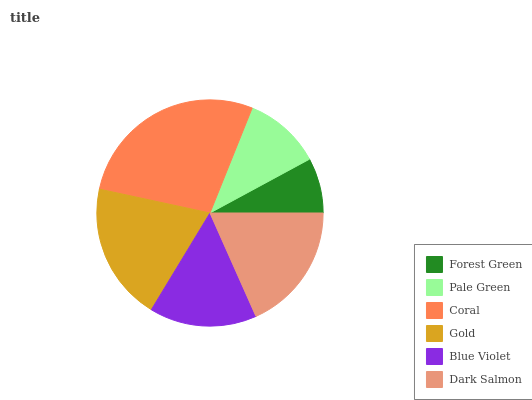Is Forest Green the minimum?
Answer yes or no. Yes. Is Coral the maximum?
Answer yes or no. Yes. Is Pale Green the minimum?
Answer yes or no. No. Is Pale Green the maximum?
Answer yes or no. No. Is Pale Green greater than Forest Green?
Answer yes or no. Yes. Is Forest Green less than Pale Green?
Answer yes or no. Yes. Is Forest Green greater than Pale Green?
Answer yes or no. No. Is Pale Green less than Forest Green?
Answer yes or no. No. Is Dark Salmon the high median?
Answer yes or no. Yes. Is Blue Violet the low median?
Answer yes or no. Yes. Is Pale Green the high median?
Answer yes or no. No. Is Coral the low median?
Answer yes or no. No. 